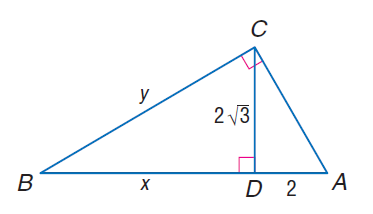Answer the mathemtical geometry problem and directly provide the correct option letter.
Question: Find y.
Choices: A: 2 \sqrt { 3 } B: 4 C: 4 \sqrt { 3 } D: 8 C 